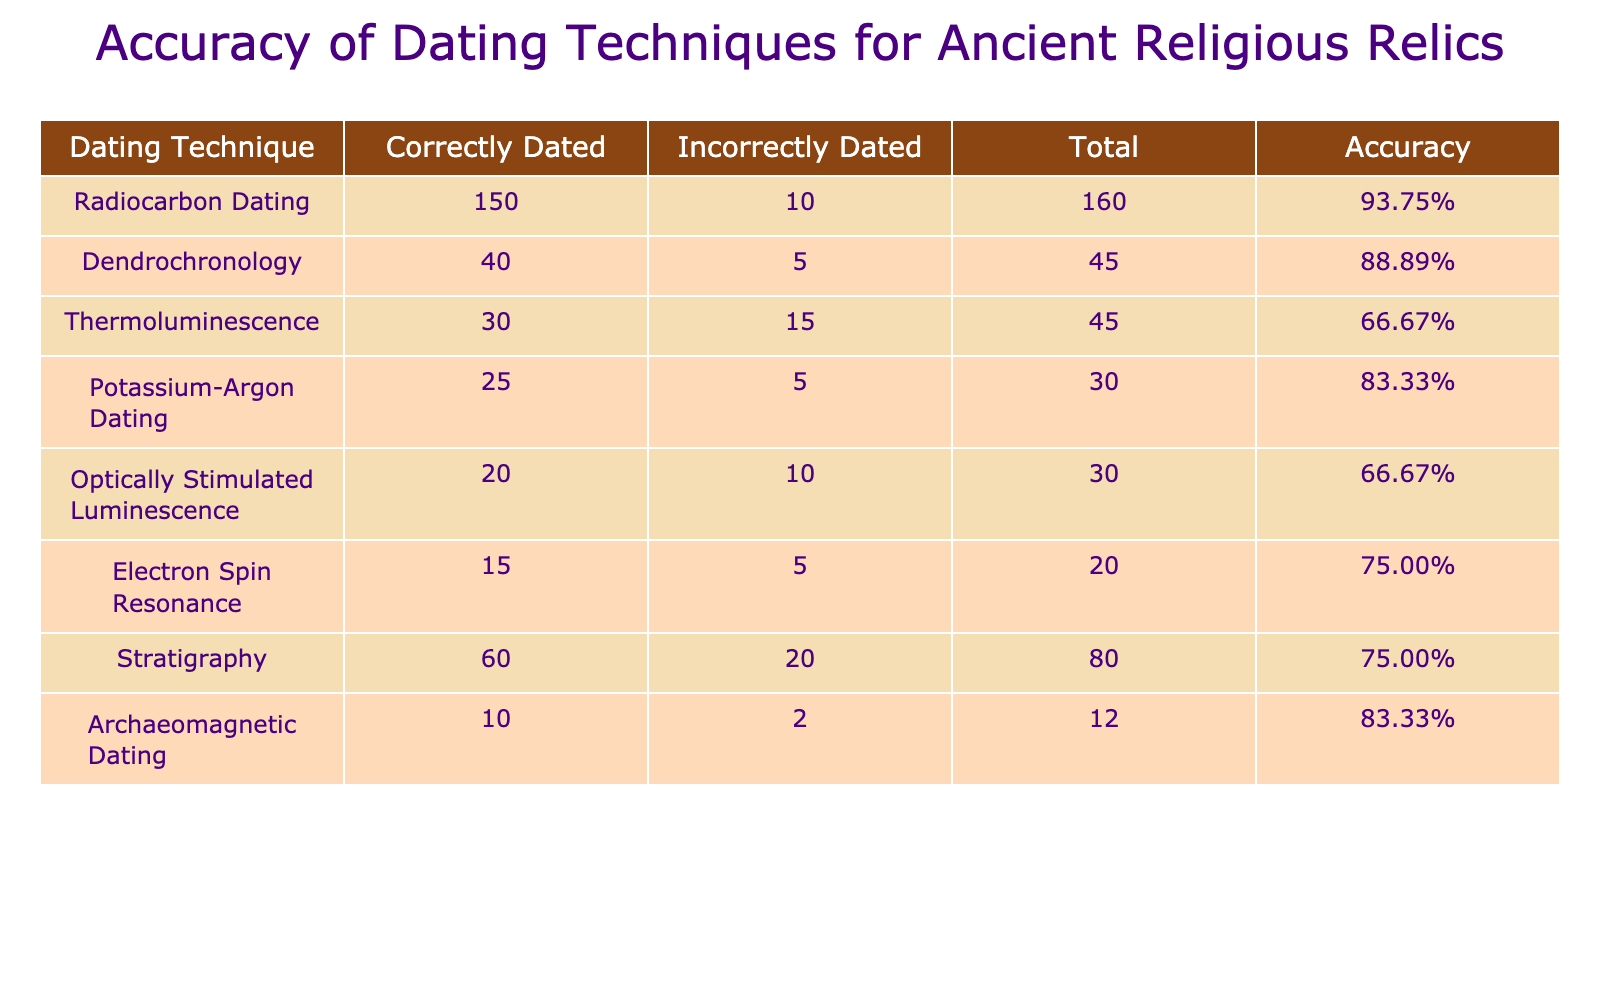What dating technique has the highest accuracy? To find the highest accuracy, we compare the accuracy rates of all dating techniques listed in the table. The accuracies are: Radiocarbon Dating (93.75%), Dendrochronology (88.89%), Thermoluminescence (66.67%), Potassium-Argon Dating (83.33%), Optically Stimulated Luminescence (66.67%), Electron Spin Resonance (75%), Stratigraphy (75%), and Archaeomagnetic Dating (83.33%). Radiocarbon Dating has the highest accuracy at 93.75%.
Answer: Radiocarbon Dating What is the total number of incorrectly dated relics for all techniques combined? To find the total incorrectly dated relics, we add the values in the "Incorrectly Dated" column: 10 (Radiocarbon) + 5 (Dendrochronology) + 15 (Thermoluminescence) + 5 (Potassium-Argon) + 10 (Optically Stimulated Luminescence) + 5 (Electron Spin Resonance) + 20 (Stratigraphy) + 2 (Archaeomagnetic) = 77.
Answer: 77 Is the accuracy of Dendrochronology greater than that of Potassium-Argon Dating? The accuracy of Dendrochronology is 88.89%, while Potassium-Argon Dating has an accuracy of 83.33%. Since 88.89% is greater than 83.33%, the statement is true.
Answer: Yes What is the average number of correctly dated relics across all techniques? To calculate the average, we sum correctly dated relics: 150 (Radiocarbon) + 40 (Dendrochronology) + 30 (Thermoluminescence) + 25 (Potassium-Argon) + 20 (Optically Stimulated Luminescence) + 15 (Electron Spin Resonance) + 60 (Stratigraphy) + 10 (Archaeomagnetic) = 350. There are 8 techniques, so we divide 350 by 8, which equals 43.75.
Answer: 43.75 Which dating technique has the lowest number of correctly dated relics? Upon reviewing the correctly dated numbers in the table, Archaeomagnetic Dating has the lowest at 10, compared to techniques that have 150, 40, 30, 25, 20, 15, and 60.
Answer: Archaeomagnetic Dating If you combine the total numbers of correctly dated relics from Radiocarbon Dating and Dendrochronology, what is the new total? Radiocarbon Dating has 150 correctly dated relics and Dendrochronology has 40. Adding them together gives us 150 + 40 = 190.
Answer: 190 Is the number of incorrectly dated relics for Thermoluminescence higher than the combined total for Electron Spin Resonance and Optically Stimulated Luminescence? Thermoluminescence has 15 incorrectly dated relics. The combined total for Electron Spin Resonance (5) and Optically Stimulated Luminescence (10) is 5 + 10 = 15. Since 15 is not higher than 15, the statement is false.
Answer: No What is the ratio of correctly dated to incorrectly dated relics for Stratigraphy? For Stratigraphy, there are 60 correctly dated and 20 incorrectly dated relics. Thus, the ratio is 60:20, which can be simplified to 3:1.
Answer: 3:1 How many dating techniques have an accuracy of over 75%? By checking the accuracies: Radiocarbon Dating (93.75%), Dendrochronology (88.89%), Potassium-Argon Dating (83.33%), and Electron Spin Resonance (75%). Techniques with over 75% are Radiocarbon, Dendrochronology, and Potassium-Argon, totaling 3 techniques.
Answer: 3 